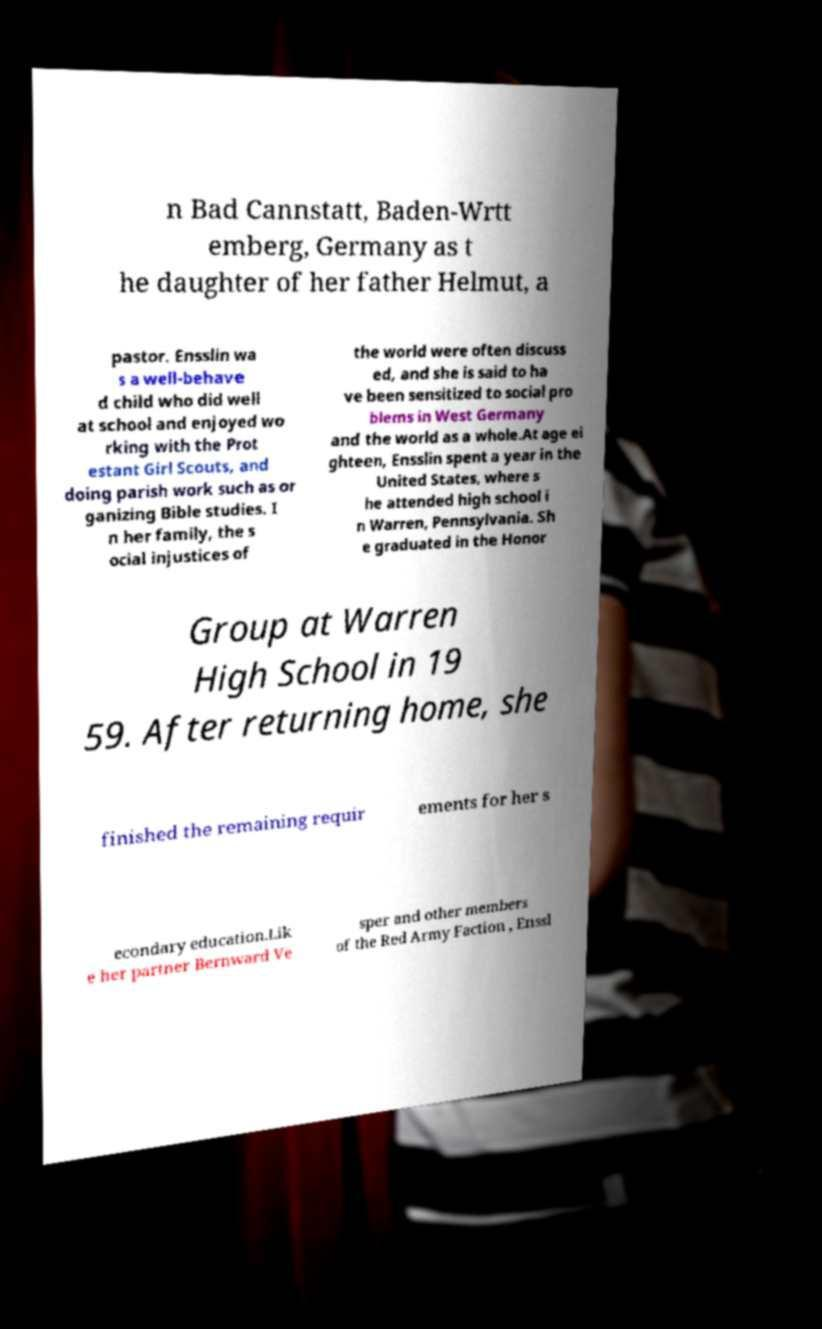Can you accurately transcribe the text from the provided image for me? n Bad Cannstatt, Baden-Wrtt emberg, Germany as t he daughter of her father Helmut, a pastor. Ensslin wa s a well-behave d child who did well at school and enjoyed wo rking with the Prot estant Girl Scouts, and doing parish work such as or ganizing Bible studies. I n her family, the s ocial injustices of the world were often discuss ed, and she is said to ha ve been sensitized to social pro blems in West Germany and the world as a whole.At age ei ghteen, Ensslin spent a year in the United States, where s he attended high school i n Warren, Pennsylvania. Sh e graduated in the Honor Group at Warren High School in 19 59. After returning home, she finished the remaining requir ements for her s econdary education.Lik e her partner Bernward Ve sper and other members of the Red Army Faction , Enssl 